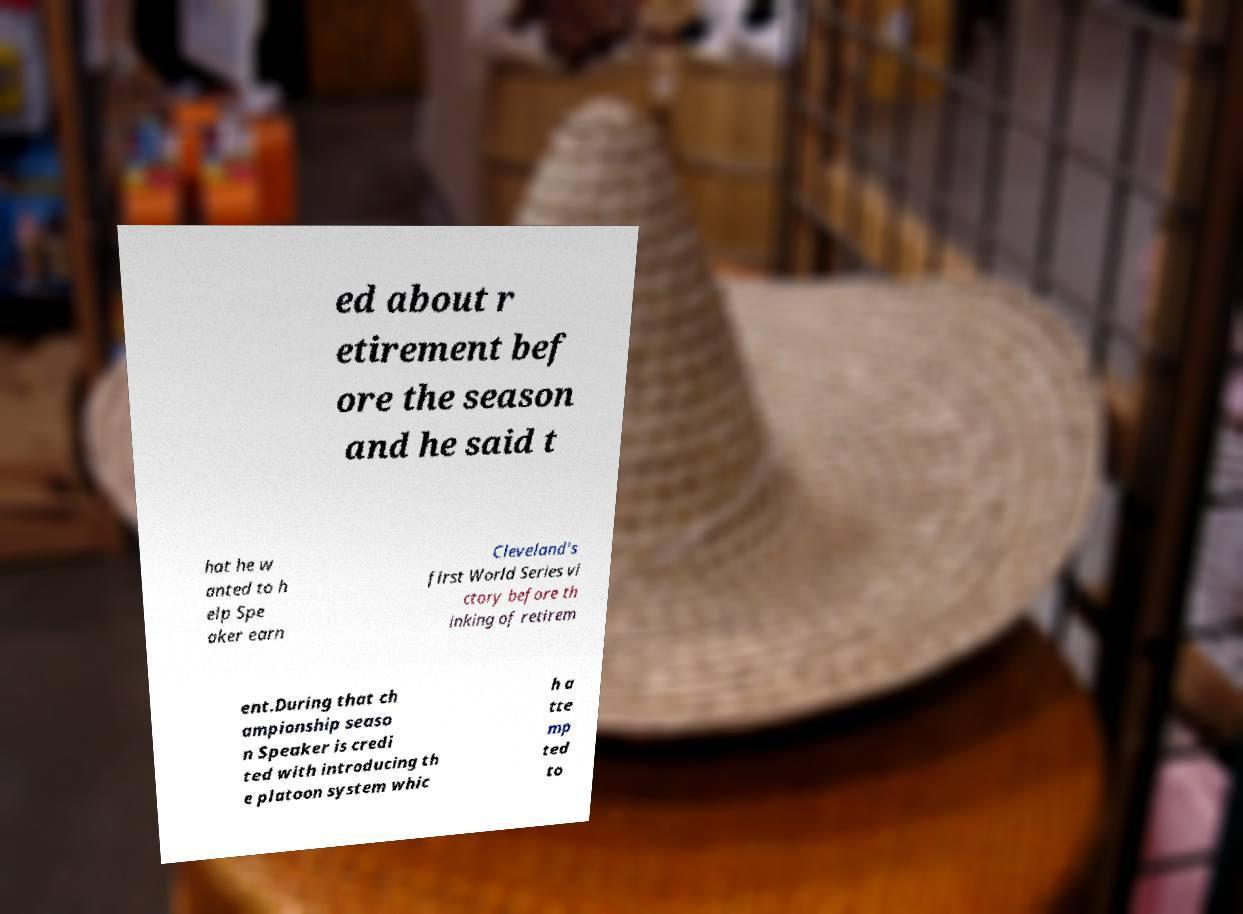Please read and relay the text visible in this image. What does it say? ed about r etirement bef ore the season and he said t hat he w anted to h elp Spe aker earn Cleveland's first World Series vi ctory before th inking of retirem ent.During that ch ampionship seaso n Speaker is credi ted with introducing th e platoon system whic h a tte mp ted to 